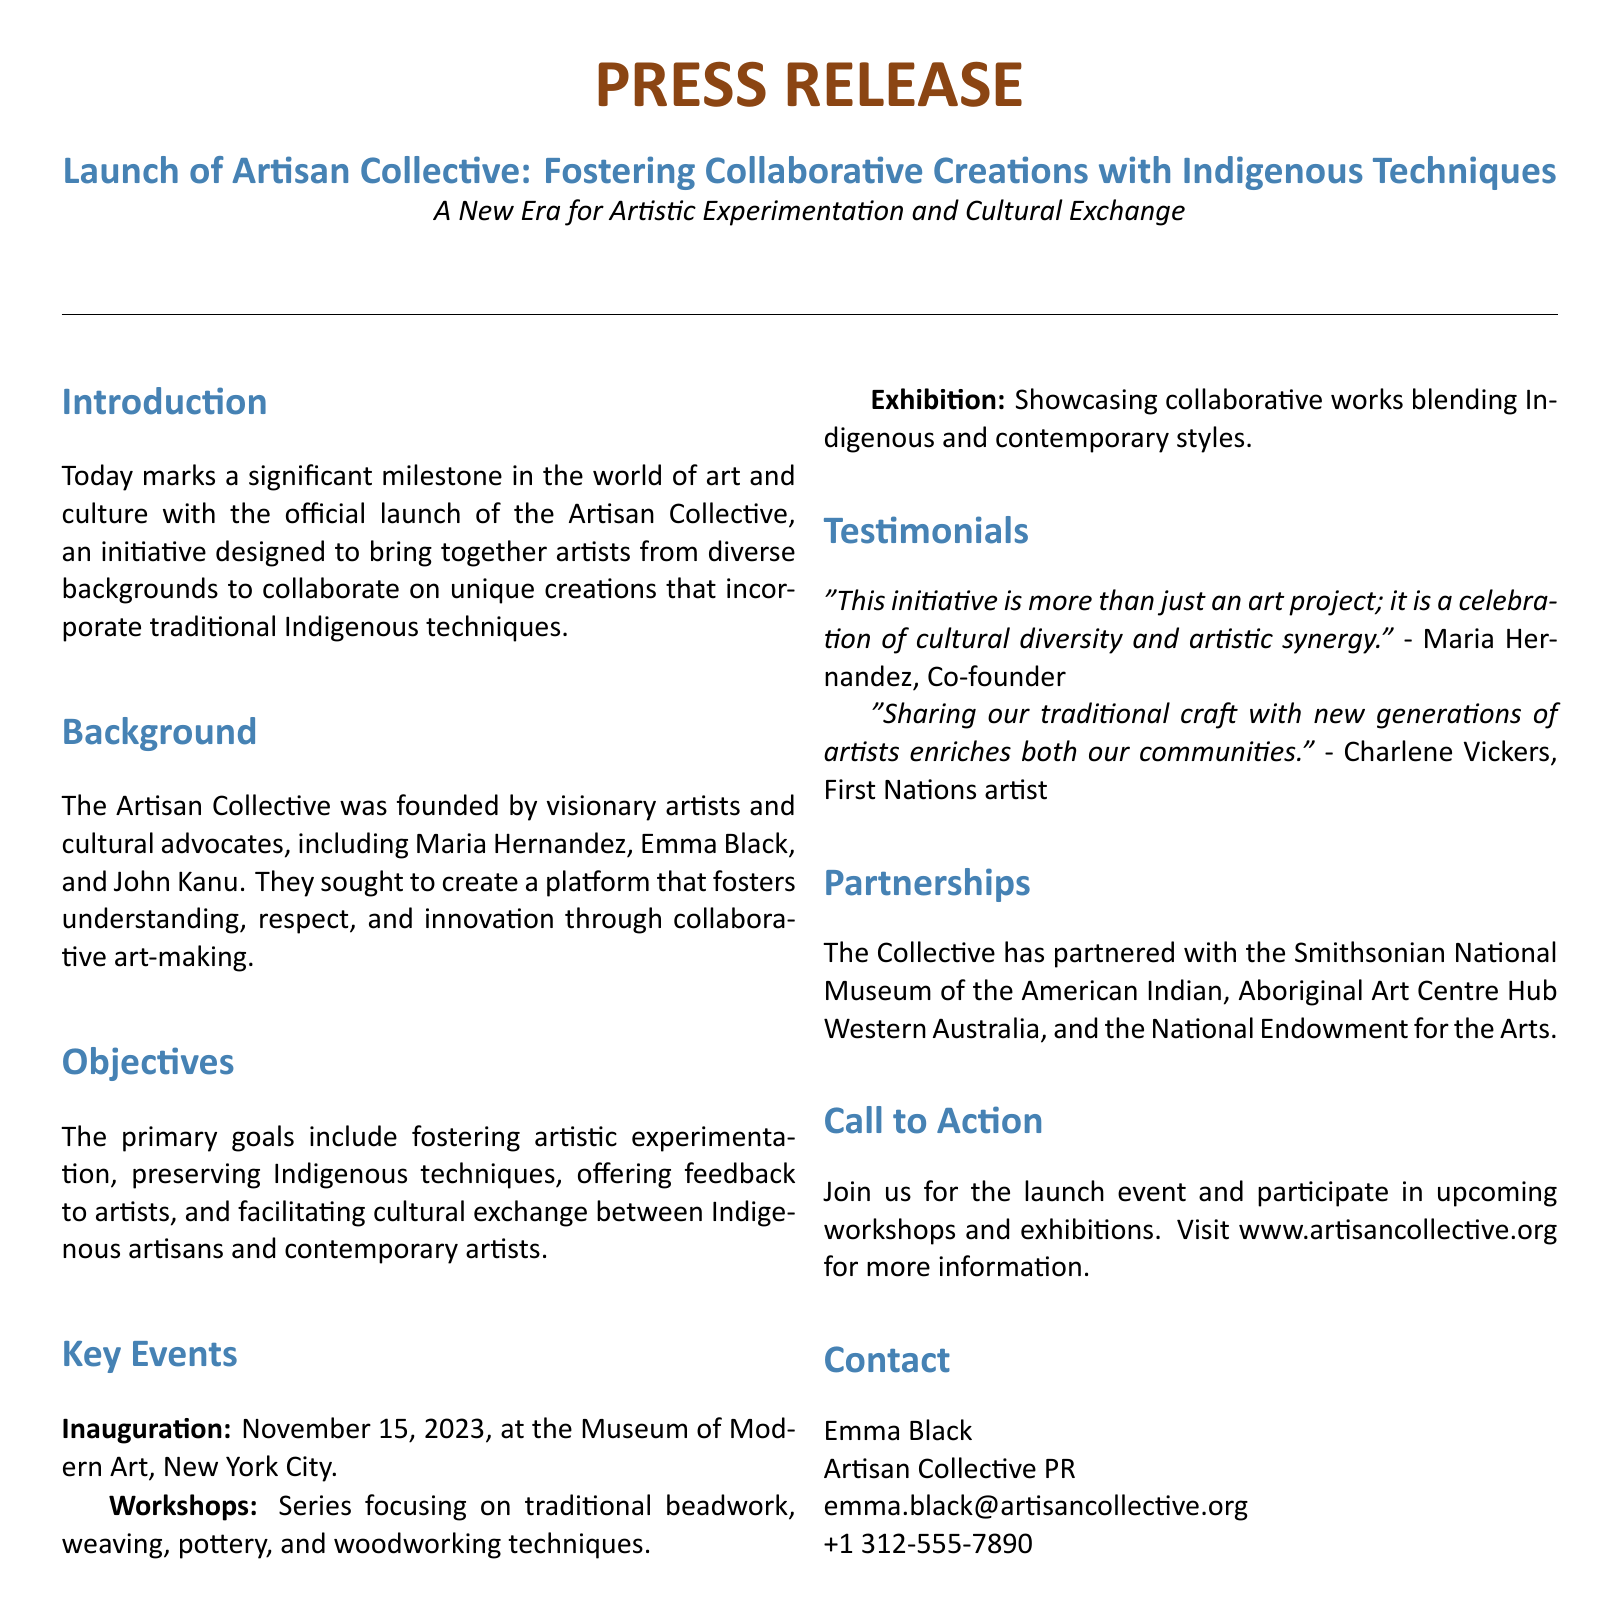What is the name of the initiative launched? The initiative aims to foster collaborative art making and it is called the Artisan Collective.
Answer: Artisan Collective Who are the co-founders of the Artisan Collective? The document lists Maria Hernandez, Emma Black, and John Kanu as the founders.
Answer: Maria Hernandez, Emma Black, and John Kanu What is the primary goal of the Artisan Collective? The document states that the primary goals include fostering artistic experimentation, preserving Indigenous techniques, and facilitating cultural exchange.
Answer: Fostering artistic experimentation When is the inauguration event scheduled? The date of the inauguration mentioned in the document is November 15, 2023.
Answer: November 15, 2023 Which museum is hosting the launch event? The launch event is being hosted at the Museum of Modern Art.
Answer: Museum of Modern Art What types of workshops are being offered? The document specifies that the workshops will focus on traditional beadwork, weaving, pottery, and woodworking techniques.
Answer: Traditional beadwork, weaving, pottery, and woodworking techniques Who is quoted in the testimonials? Maria Hernandez and Charlene Vickers are the individuals quoted in the testimonials section.
Answer: Maria Hernandez and Charlene Vickers What partnerships has the Artisan Collective formed? The document mentions partnerships with the Smithsonian National Museum of the American Indian, Aboriginal Art Centre Hub Western Australia, and the National Endowment for the Arts.
Answer: Smithsonian National Museum of the American Indian, Aboriginal Art Centre Hub Western Australia, and the National Endowment for the Arts What kind of exhibition will be showcased? The exhibition will showcase collaborative works blending Indigenous and contemporary styles.
Answer: Collaborative works blending Indigenous and contemporary styles 